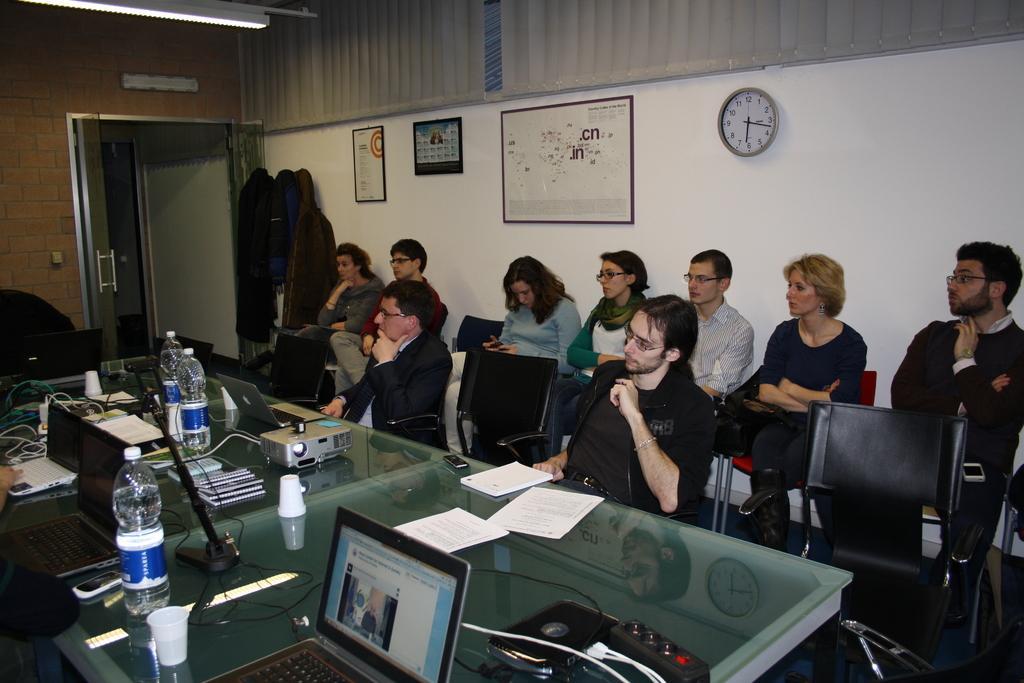Can you describe this image briefly? In this image I can see group of people sitting on the chairs, in front I can see two laptops, few bottles on the table. Background I can see a clock and few frames attached to the wall and the wall is in white color. 